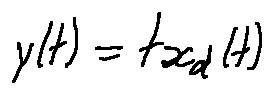Convert formula to latex. <formula><loc_0><loc_0><loc_500><loc_500>y ( t ) = t x _ { d } ( t )</formula> 